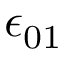<formula> <loc_0><loc_0><loc_500><loc_500>\epsilon _ { 0 1 }</formula> 